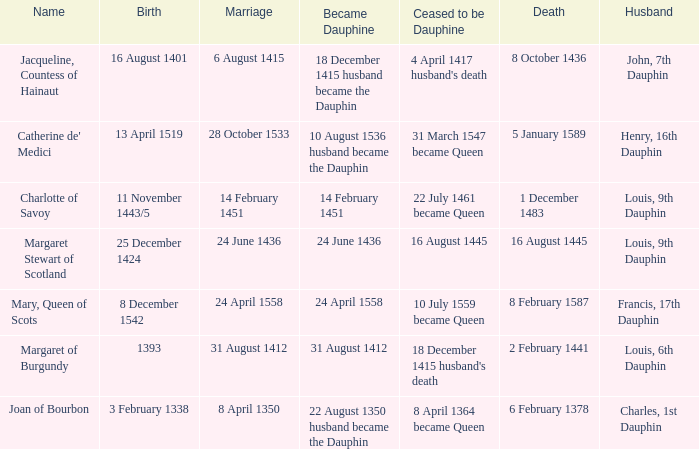When was became dauphine when birth is 1393? 31 August 1412. 